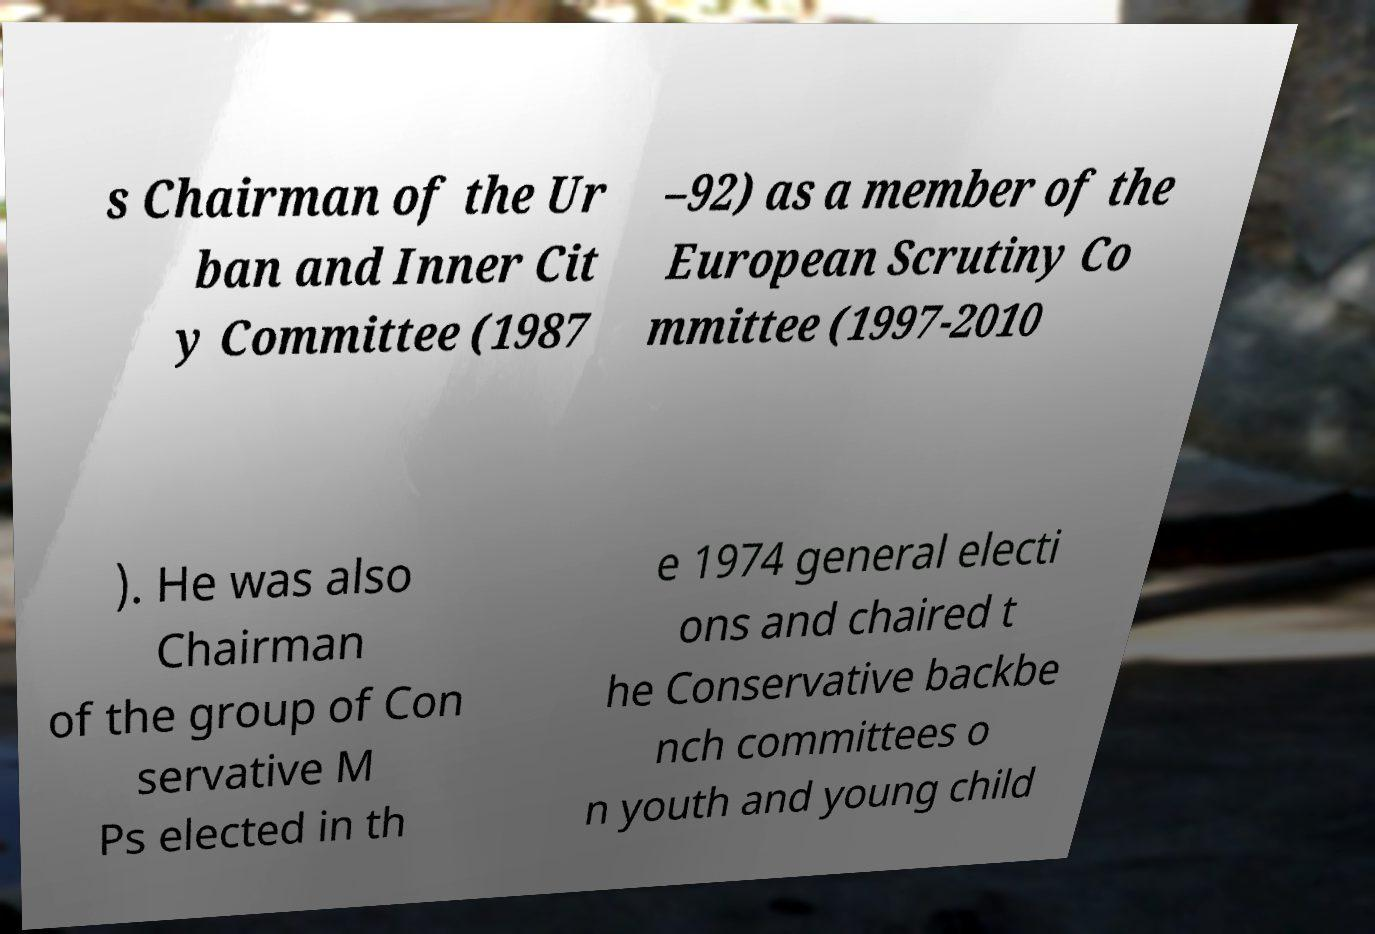I need the written content from this picture converted into text. Can you do that? s Chairman of the Ur ban and Inner Cit y Committee (1987 –92) as a member of the European Scrutiny Co mmittee (1997-2010 ). He was also Chairman of the group of Con servative M Ps elected in th e 1974 general electi ons and chaired t he Conservative backbe nch committees o n youth and young child 